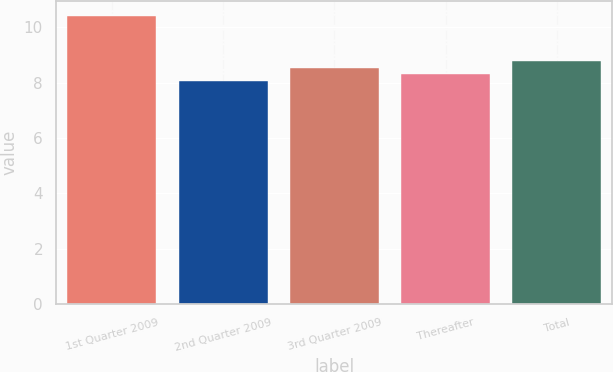Convert chart to OTSL. <chart><loc_0><loc_0><loc_500><loc_500><bar_chart><fcel>1st Quarter 2009<fcel>2nd Quarter 2009<fcel>3rd Quarter 2009<fcel>Thereafter<fcel>Total<nl><fcel>10.42<fcel>8.08<fcel>8.54<fcel>8.31<fcel>8.77<nl></chart> 